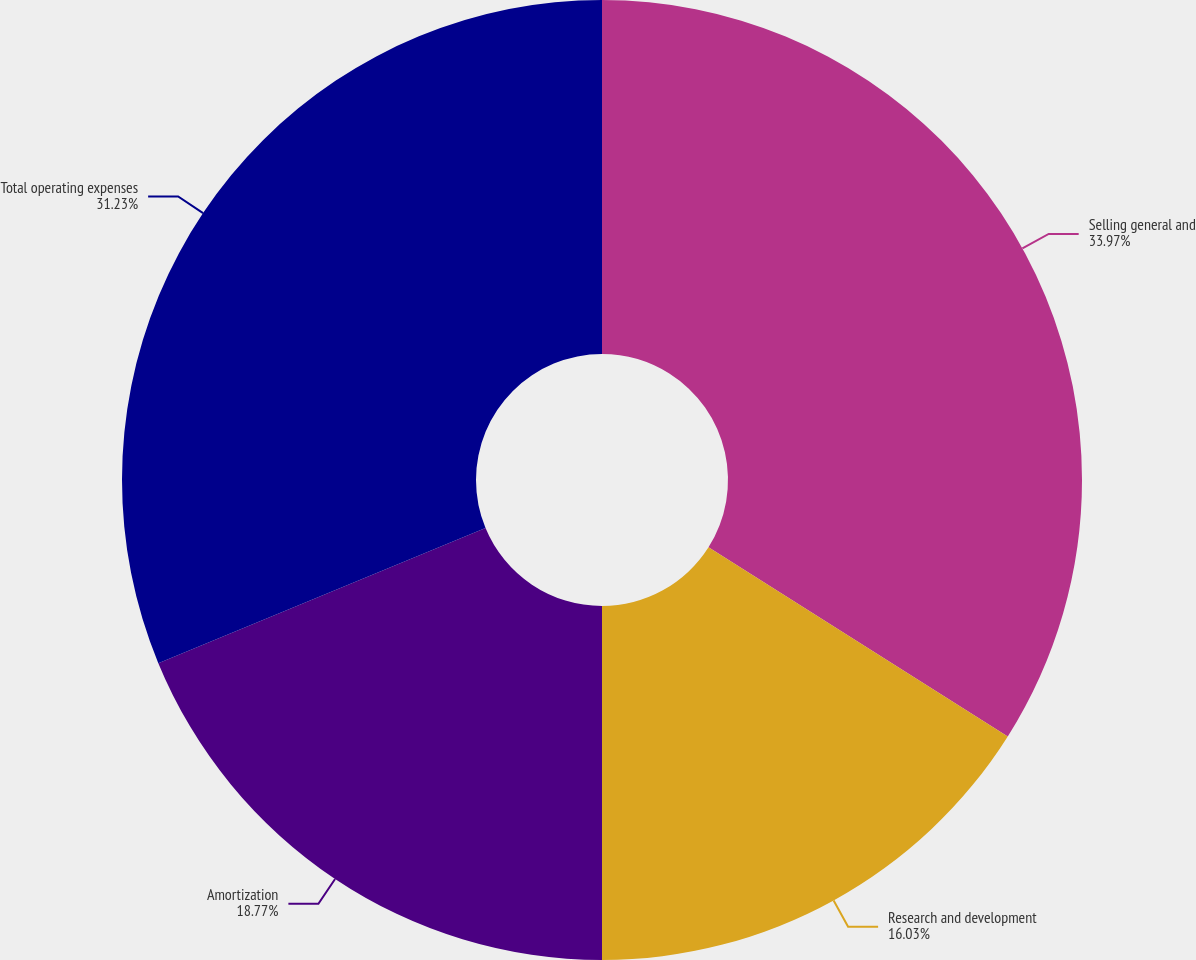<chart> <loc_0><loc_0><loc_500><loc_500><pie_chart><fcel>Selling general and<fcel>Research and development<fcel>Amortization<fcel>Total operating expenses<nl><fcel>33.97%<fcel>16.03%<fcel>18.77%<fcel>31.23%<nl></chart> 